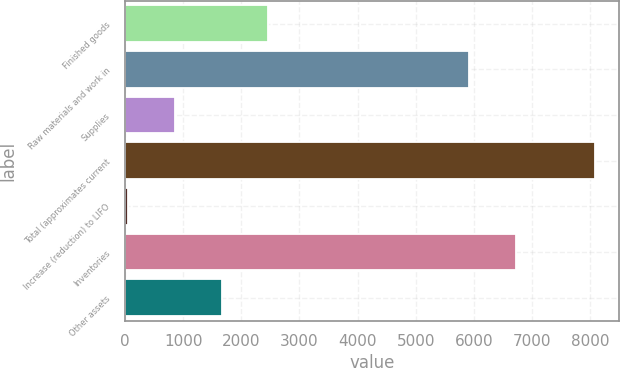<chart> <loc_0><loc_0><loc_500><loc_500><bar_chart><fcel>Finished goods<fcel>Raw materials and work in<fcel>Supplies<fcel>Total (approximates current<fcel>Increase (reduction) to LIFO<fcel>Inventories<fcel>Other assets<nl><fcel>2463.1<fcel>5921<fcel>855.7<fcel>8089<fcel>52<fcel>6724.7<fcel>1659.4<nl></chart> 